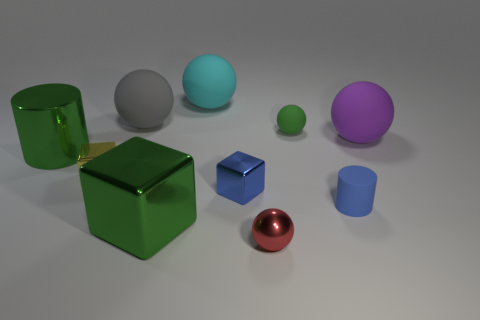How many other things are there of the same color as the big cylinder?
Make the answer very short. 2. There is a matte sphere that is to the right of the red object and behind the purple rubber sphere; what is its color?
Offer a terse response. Green. Is there a big blue rubber object that has the same shape as the big purple thing?
Offer a very short reply. No. Do the metallic sphere and the large cube have the same color?
Ensure brevity in your answer.  No. There is a large metal object left of the big gray object; are there any shiny cylinders behind it?
Your response must be concise. No. What number of objects are either objects that are behind the large green metal block or small spheres behind the red object?
Keep it short and to the point. 8. How many objects are either big green cylinders or rubber balls that are behind the purple thing?
Give a very brief answer. 4. What size is the rubber thing to the left of the large green metallic object that is in front of the cylinder behind the yellow metal block?
Offer a very short reply. Large. There is a green object that is the same size as the blue cube; what is it made of?
Keep it short and to the point. Rubber. Are there any brown blocks of the same size as the purple rubber sphere?
Ensure brevity in your answer.  No. 